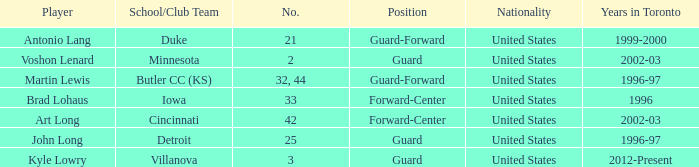What player played guard for toronto in 1996-97? John Long. 